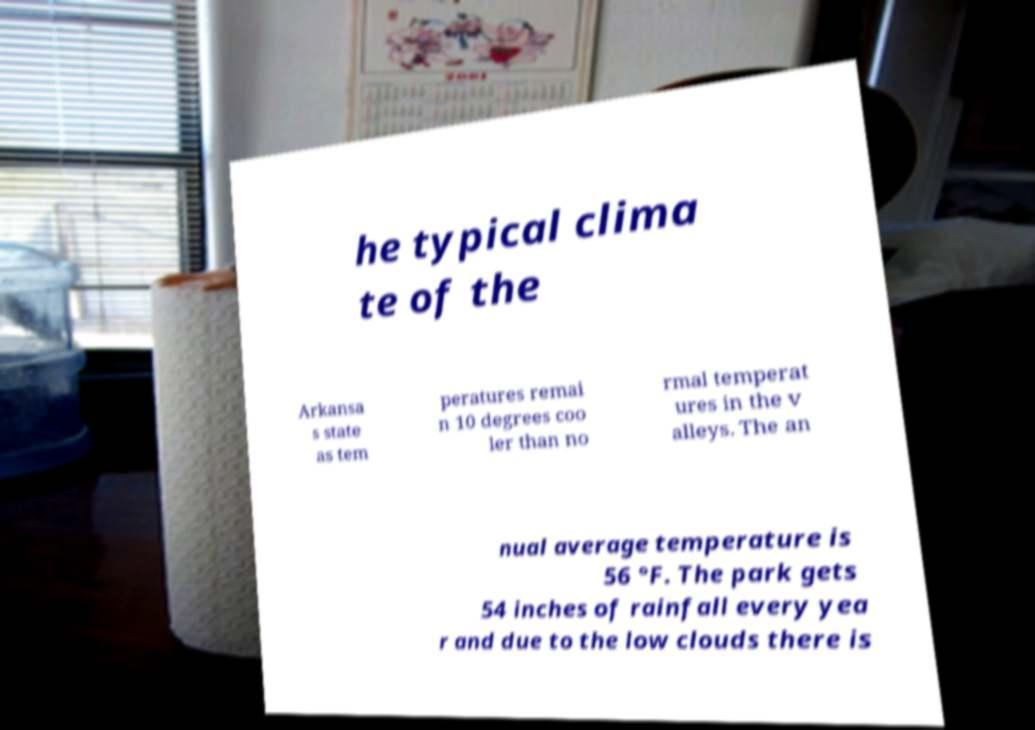Can you accurately transcribe the text from the provided image for me? he typical clima te of the Arkansa s state as tem peratures remai n 10 degrees coo ler than no rmal temperat ures in the v alleys. The an nual average temperature is 56 °F. The park gets 54 inches of rainfall every yea r and due to the low clouds there is 